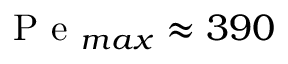<formula> <loc_0><loc_0><loc_500><loc_500>P e _ { \max } \approx 3 9 0</formula> 